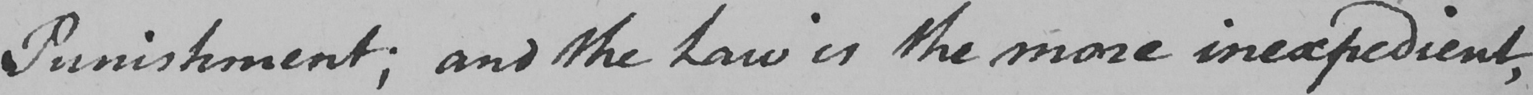Transcribe the text shown in this historical manuscript line. Punishment ; and the Law is the more inexpedient , 